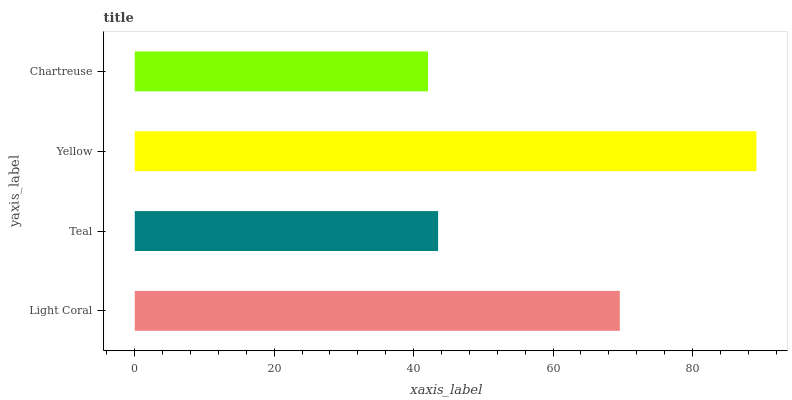Is Chartreuse the minimum?
Answer yes or no. Yes. Is Yellow the maximum?
Answer yes or no. Yes. Is Teal the minimum?
Answer yes or no. No. Is Teal the maximum?
Answer yes or no. No. Is Light Coral greater than Teal?
Answer yes or no. Yes. Is Teal less than Light Coral?
Answer yes or no. Yes. Is Teal greater than Light Coral?
Answer yes or no. No. Is Light Coral less than Teal?
Answer yes or no. No. Is Light Coral the high median?
Answer yes or no. Yes. Is Teal the low median?
Answer yes or no. Yes. Is Teal the high median?
Answer yes or no. No. Is Yellow the low median?
Answer yes or no. No. 